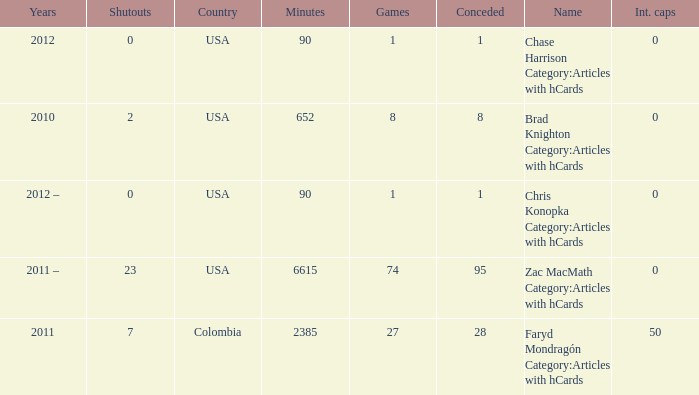When chase harrison category:articles with hcards is the name what is the year? 2012.0. 